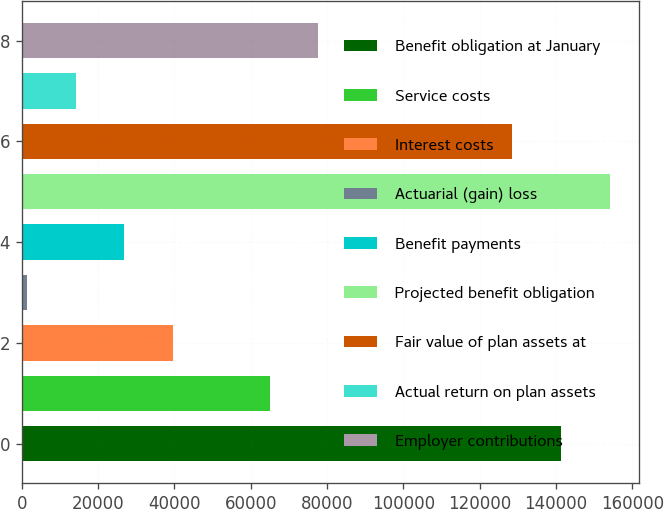Convert chart to OTSL. <chart><loc_0><loc_0><loc_500><loc_500><bar_chart><fcel>Benefit obligation at January<fcel>Service costs<fcel>Interest costs<fcel>Actuarial (gain) loss<fcel>Benefit payments<fcel>Projected benefit obligation<fcel>Fair value of plan assets at<fcel>Actual return on plan assets<fcel>Employer contributions<nl><fcel>141283<fcel>64985<fcel>39552.2<fcel>1403<fcel>26835.8<fcel>154000<fcel>128567<fcel>14119.4<fcel>77701.4<nl></chart> 